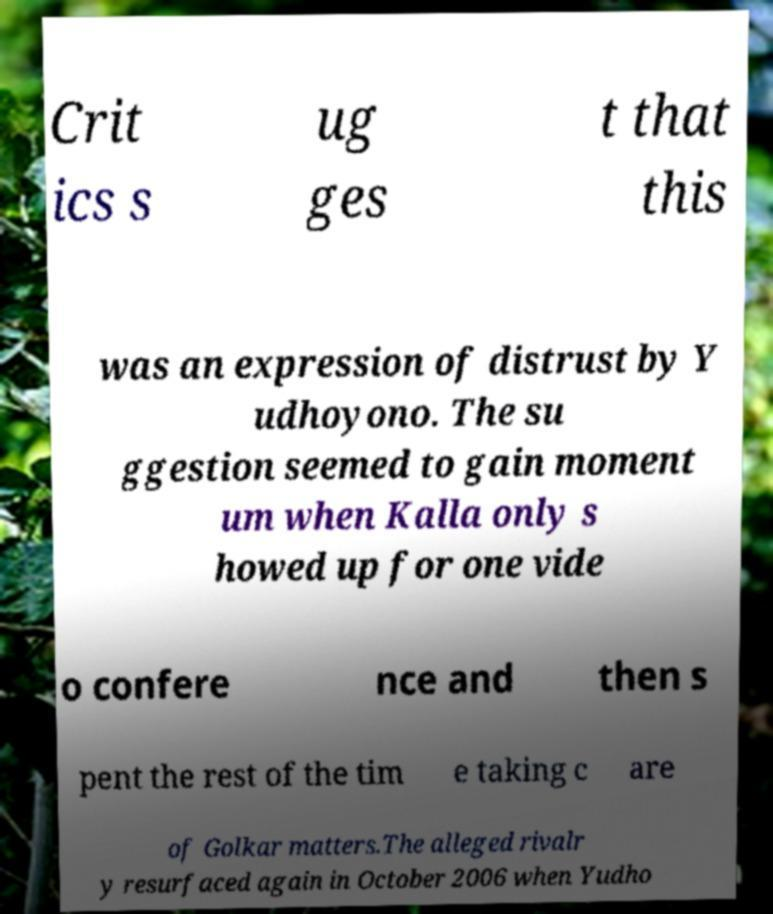Please read and relay the text visible in this image. What does it say? Crit ics s ug ges t that this was an expression of distrust by Y udhoyono. The su ggestion seemed to gain moment um when Kalla only s howed up for one vide o confere nce and then s pent the rest of the tim e taking c are of Golkar matters.The alleged rivalr y resurfaced again in October 2006 when Yudho 